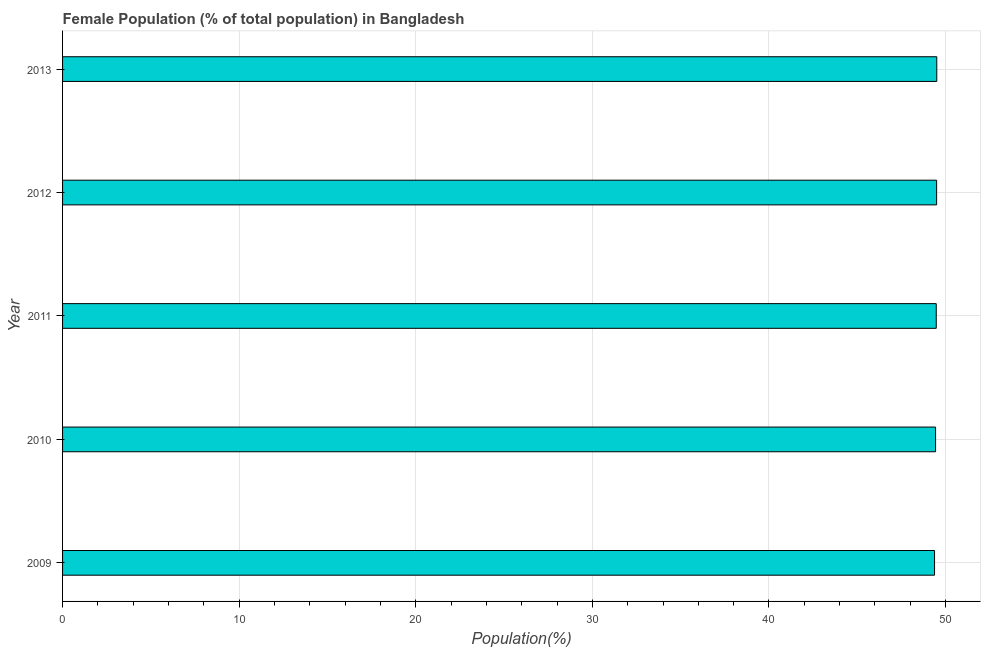What is the title of the graph?
Give a very brief answer. Female Population (% of total population) in Bangladesh. What is the label or title of the X-axis?
Your answer should be compact. Population(%). What is the label or title of the Y-axis?
Provide a succinct answer. Year. What is the female population in 2009?
Make the answer very short. 49.38. Across all years, what is the maximum female population?
Offer a terse response. 49.5. Across all years, what is the minimum female population?
Provide a short and direct response. 49.38. In which year was the female population minimum?
Your response must be concise. 2009. What is the sum of the female population?
Offer a very short reply. 247.28. What is the difference between the female population in 2009 and 2011?
Your response must be concise. -0.1. What is the average female population per year?
Ensure brevity in your answer.  49.45. What is the median female population?
Keep it short and to the point. 49.47. In how many years, is the female population greater than 42 %?
Your answer should be compact. 5. Do a majority of the years between 2010 and 2013 (inclusive) have female population greater than 16 %?
Provide a succinct answer. Yes. What is the ratio of the female population in 2011 to that in 2013?
Provide a short and direct response. 1. Is the female population in 2010 less than that in 2013?
Your answer should be compact. Yes. Is the difference between the female population in 2010 and 2012 greater than the difference between any two years?
Your answer should be compact. No. What is the difference between the highest and the second highest female population?
Make the answer very short. 0.01. What is the difference between the highest and the lowest female population?
Provide a short and direct response. 0.13. How many years are there in the graph?
Your answer should be compact. 5. What is the difference between two consecutive major ticks on the X-axis?
Ensure brevity in your answer.  10. Are the values on the major ticks of X-axis written in scientific E-notation?
Ensure brevity in your answer.  No. What is the Population(%) of 2009?
Keep it short and to the point. 49.38. What is the Population(%) in 2010?
Your answer should be compact. 49.43. What is the Population(%) of 2011?
Provide a short and direct response. 49.47. What is the Population(%) of 2012?
Provide a short and direct response. 49.49. What is the Population(%) of 2013?
Keep it short and to the point. 49.5. What is the difference between the Population(%) in 2009 and 2010?
Keep it short and to the point. -0.06. What is the difference between the Population(%) in 2009 and 2011?
Your answer should be very brief. -0.1. What is the difference between the Population(%) in 2009 and 2012?
Make the answer very short. -0.12. What is the difference between the Population(%) in 2009 and 2013?
Provide a succinct answer. -0.13. What is the difference between the Population(%) in 2010 and 2011?
Provide a short and direct response. -0.04. What is the difference between the Population(%) in 2010 and 2012?
Ensure brevity in your answer.  -0.06. What is the difference between the Population(%) in 2010 and 2013?
Keep it short and to the point. -0.07. What is the difference between the Population(%) in 2011 and 2012?
Give a very brief answer. -0.02. What is the difference between the Population(%) in 2011 and 2013?
Give a very brief answer. -0.03. What is the difference between the Population(%) in 2012 and 2013?
Offer a very short reply. -0.01. What is the ratio of the Population(%) in 2009 to that in 2013?
Your response must be concise. 1. What is the ratio of the Population(%) in 2010 to that in 2011?
Give a very brief answer. 1. What is the ratio of the Population(%) in 2010 to that in 2012?
Offer a terse response. 1. What is the ratio of the Population(%) in 2010 to that in 2013?
Provide a short and direct response. 1. What is the ratio of the Population(%) in 2011 to that in 2012?
Your response must be concise. 1. What is the ratio of the Population(%) in 2011 to that in 2013?
Ensure brevity in your answer.  1. What is the ratio of the Population(%) in 2012 to that in 2013?
Offer a terse response. 1. 